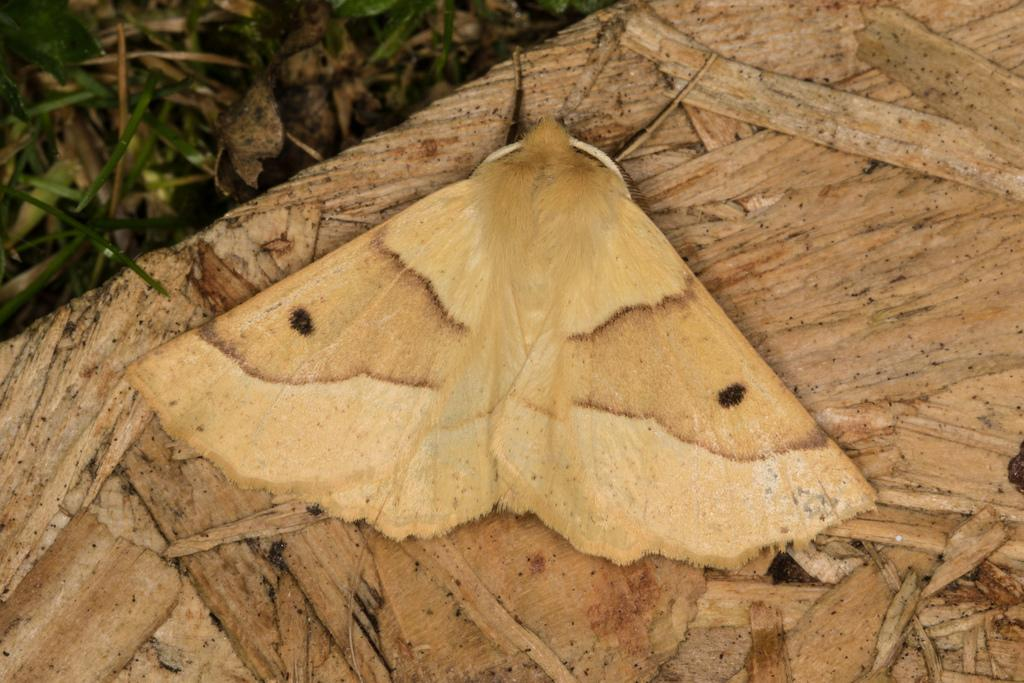What is present on the wooden surface in the image? There is an insect on a wooden surface in the image. What type of vegetation can be seen in the image? There is grass visible in the image. What color is the coat hanging on the nail in the image? There is no coat or nail present in the image; it only features an insect on a wooden surface and grass. 